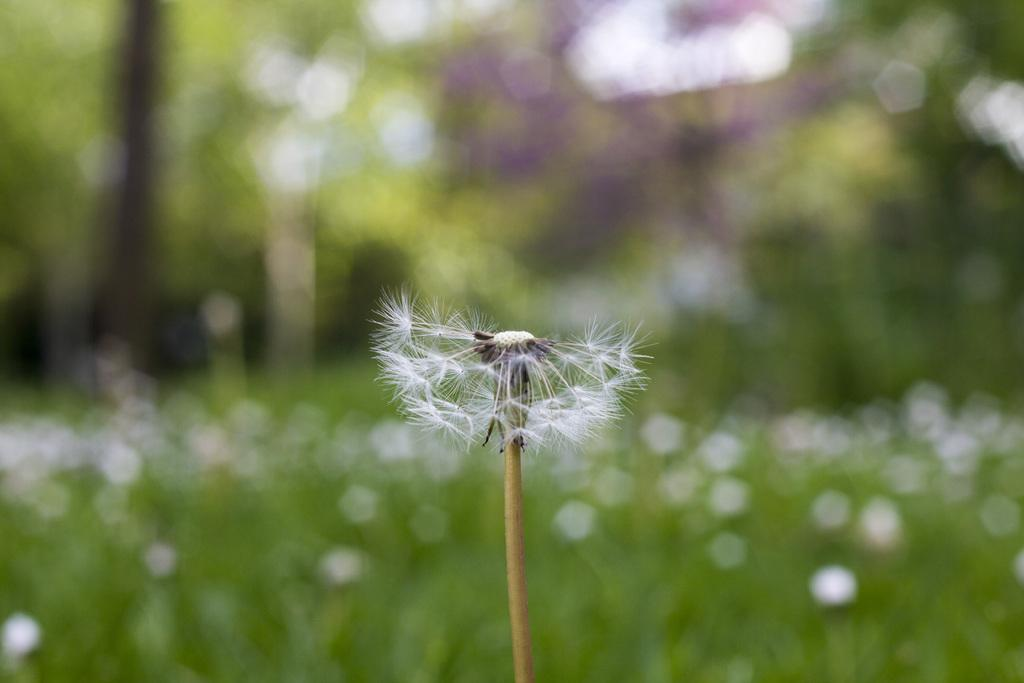What is the main subject of the image? There is a flower in the image. Can you describe the color of the flower? The flower is white in color. What type of frame is around the authority figure in the image? There is no frame or authority figure present in the image; it only features a white flower. 